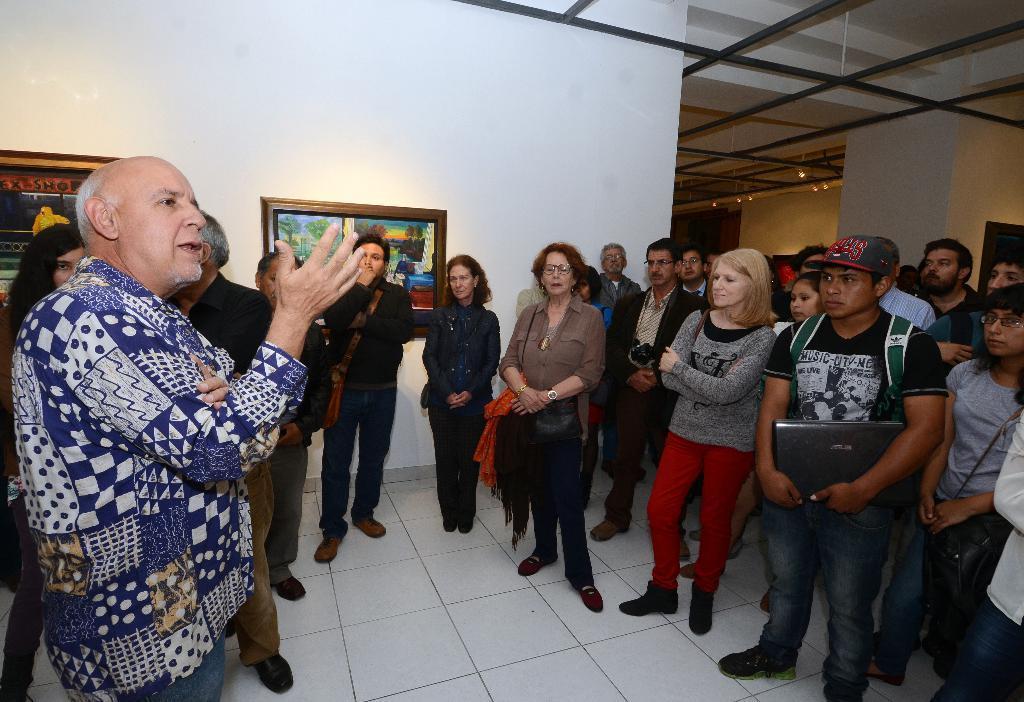Describe this image in one or two sentences. This image is taken indoors. At the bottom of the image there is a floor. In the background there are a few walls with picture frames. At the top of the image there is a roof with a few lights. On the right side of the image many people are standing on the floor. 